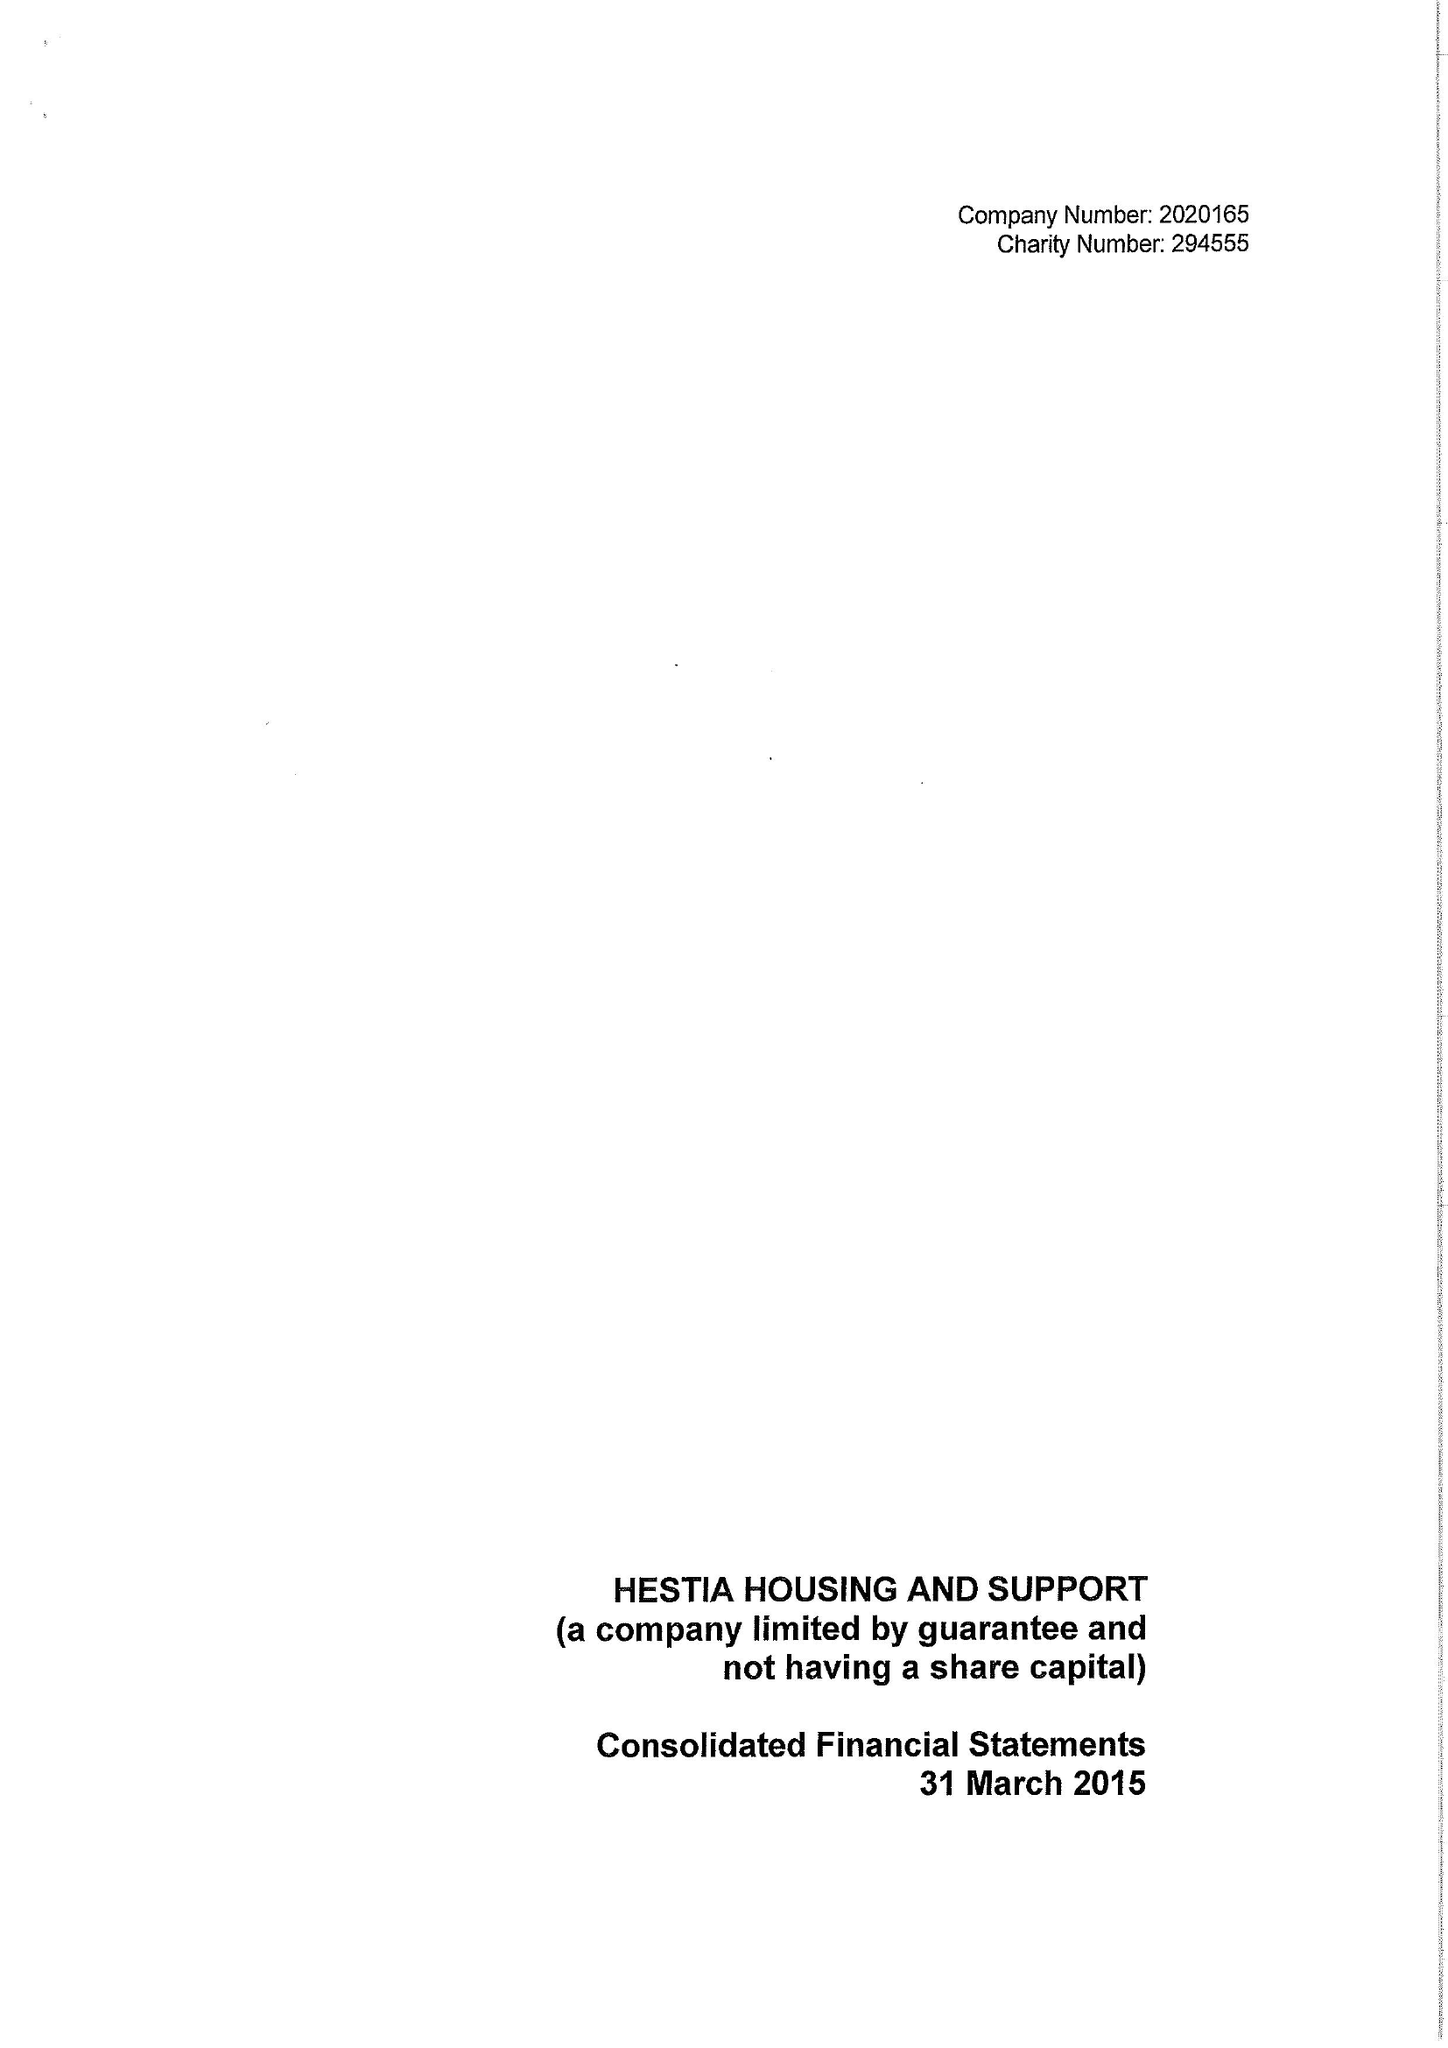What is the value for the address__post_town?
Answer the question using a single word or phrase. LONDON 